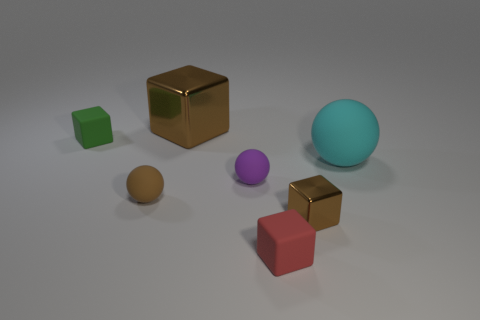There is a small sphere that is the same color as the big metallic cube; what material is it?
Keep it short and to the point. Rubber. There is a small object to the left of the brown rubber object left of the shiny thing behind the big rubber thing; what color is it?
Your answer should be compact. Green. What number of shiny things have the same size as the cyan rubber ball?
Your answer should be very brief. 1. What is the color of the tiny ball on the right side of the big brown object?
Your response must be concise. Purple. How many other objects are there of the same size as the cyan rubber thing?
Offer a very short reply. 1. What is the size of the object that is on the left side of the large brown thing and in front of the cyan sphere?
Your answer should be compact. Small. Do the big metal block and the small thing that is behind the big matte ball have the same color?
Ensure brevity in your answer.  No. Are there any red things that have the same shape as the large brown shiny thing?
Offer a very short reply. Yes. What number of objects are red matte cubes or things that are behind the big sphere?
Ensure brevity in your answer.  3. What number of other objects are the same material as the small purple sphere?
Give a very brief answer. 4. 